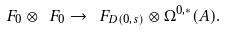<formula> <loc_0><loc_0><loc_500><loc_500>\ F _ { 0 } \otimes \ F _ { 0 } \to \ F _ { D ( 0 , s ) } \otimes \Omega ^ { 0 , \ast } ( A ) .</formula> 